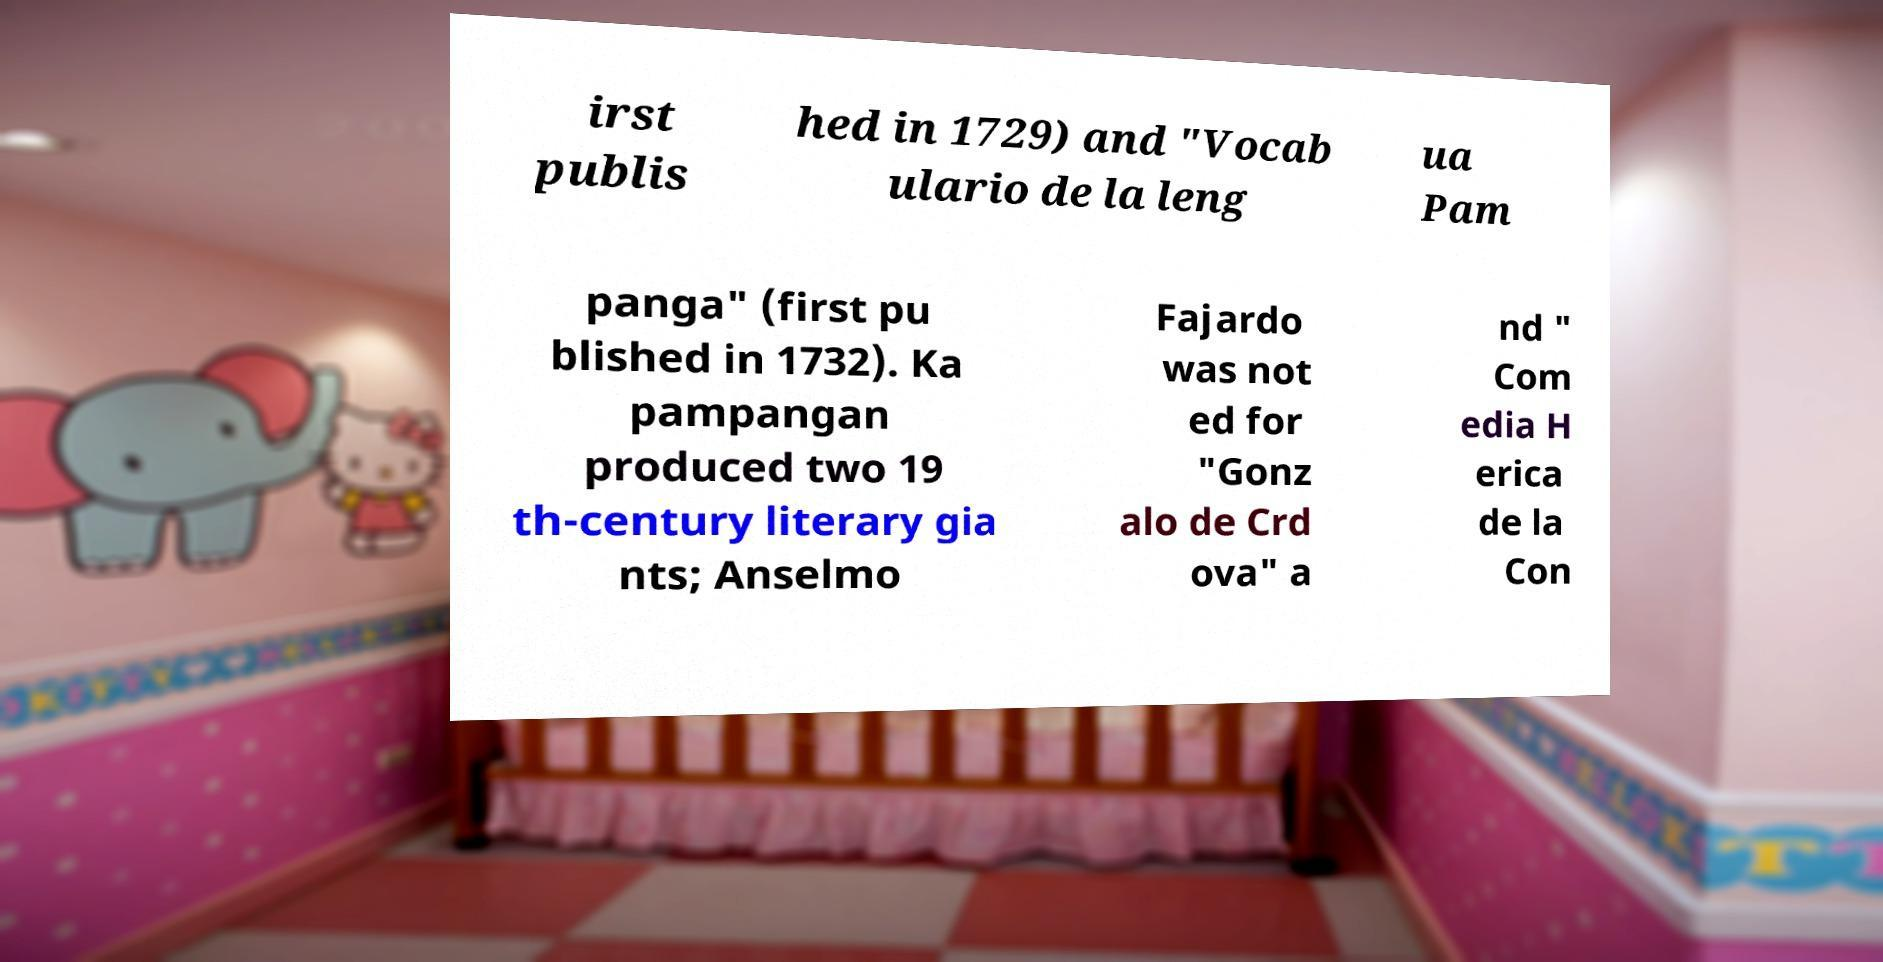Please identify and transcribe the text found in this image. irst publis hed in 1729) and "Vocab ulario de la leng ua Pam panga" (first pu blished in 1732). Ka pampangan produced two 19 th-century literary gia nts; Anselmo Fajardo was not ed for "Gonz alo de Crd ova" a nd " Com edia H erica de la Con 